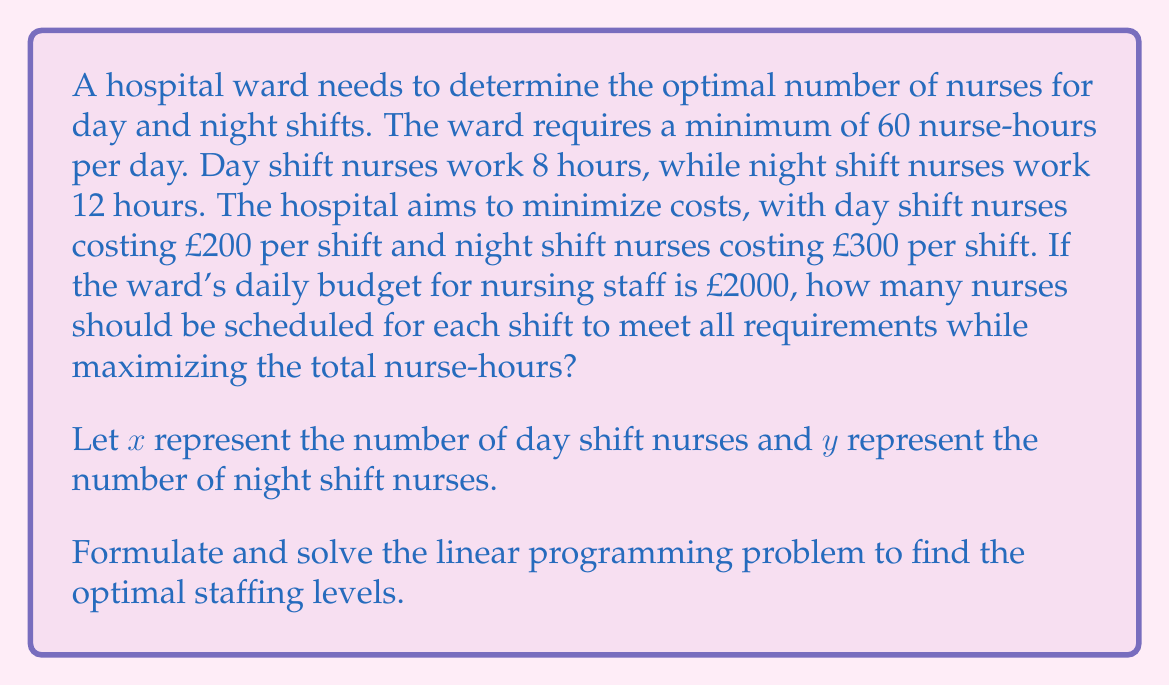Could you help me with this problem? Let's approach this step-by-step:

1. Set up the constraints:
   a. Nurse-hours: $8x + 12y \geq 60$
   b. Budget: $200x + 300y \leq 2000$
   c. Non-negativity: $x \geq 0$, $y \geq 0$

2. Objective function:
   Maximize $z = 8x + 12y$ (total nurse-hours)

3. Convert the inequalities to equations:
   $8x + 12y = 60 + s_1$  (where $s_1$ is slack variable)
   $200x + 300y + s_2 = 2000$  (where $s_2$ is surplus variable)

4. Express $y$ in terms of $x$ using the budget constraint:
   $300y = 2000 - 200x - s_2$
   $y = \frac{2000 - 200x - s_2}{300}$

5. Substitute this into the nurse-hours constraint:
   $8x + 12(\frac{2000 - 200x - s_2}{300}) = 60 + s_1$
   $8x + 80 - 8x - \frac{s_2}{25} = 60 + s_1$
   $80 - \frac{s_2}{25} = 60 + s_1$
   $20 = s_1 + \frac{s_2}{25}$

6. To maximize nurse-hours, we want $s_1 = 0$ and $s_2 = 500$:
   $20 = 0 + \frac{500}{25}$

7. Substitute back into the budget constraint:
   $200x + 300y = 1500$

8. Solve simultaneously with the nurse-hours constraint:
   $8x + 12y = 60$
   $25x + 37.5y = 187.5$

   Subtracting the first equation from the second:
   $17x + 25.5y = 127.5$
   $x + 1.5y = 7.5$

9. Substitute into the nurse-hours constraint:
   $8(7.5 - 1.5y) + 12y = 60$
   $60 - 12y + 12y = 60$
   $60 = 60$

   This confirms our solution.

10. Solve for $x$ and $y$:
    $x = 7.5 - 1.5y$
    $y = 5$
    $x = 7.5 - 1.5(5) = 0$

Therefore, the optimal staffing is 0 day shift nurses and 5 night shift nurses.
Answer: 0 day shift nurses, 5 night shift nurses 